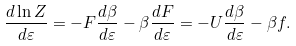Convert formula to latex. <formula><loc_0><loc_0><loc_500><loc_500>\frac { d \ln Z } { d \varepsilon } = - F \frac { d \beta } { d \varepsilon } - \beta \frac { d F } { d \varepsilon } = - U \frac { d \beta } { d \varepsilon } - \beta f .</formula> 